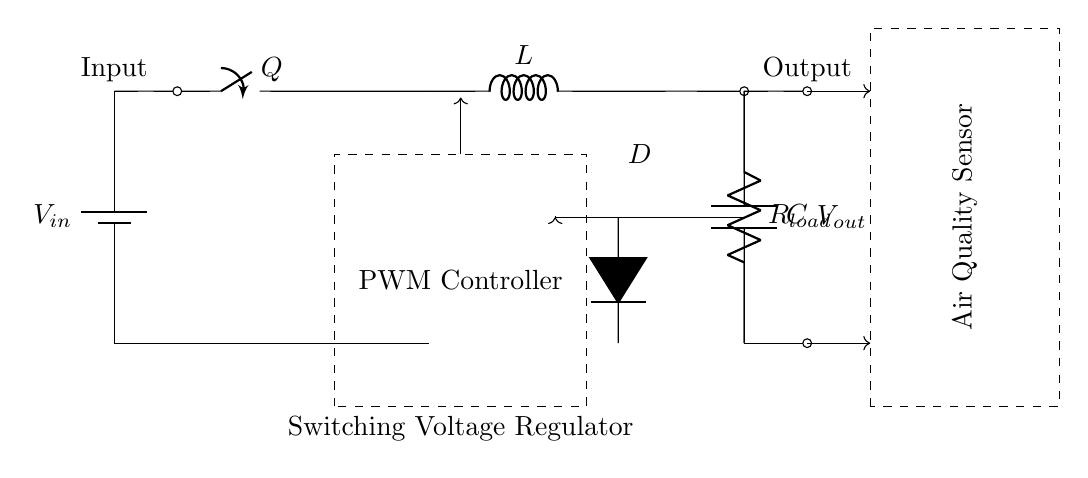What are the components in the circuit? The circuit includes a battery, a switch, an inductor, a diode, a capacitor, a load resistor, and a PWM controller.
Answer: battery, switch, inductor, diode, capacitor, load resistor, PWM controller What does the PWM controller do? The PWM controller regulates the output voltage by controlling the duty cycle of the switch. This results in efficient energy transfer to the load.
Answer: regulate output voltage What is the role of the inductor in this circuit? The inductor stores energy in a magnetic field when current flows through it and releases it when the current stops. This helps in maintaining a steady output voltage.
Answer: store energy What happens to the voltage when the switch is closed? Closing the switch allows current to flow through the inductor, which starts charging the capacitor, resulting in an increase in output voltage.
Answer: output voltage increases Why is the diode included in the circuit? The diode allows current to flow in only one direction, preventing the capacitor from discharging back into the inductor when the switch opens.
Answer: prevent reverse current What type of regulator is this circuit an example of? This circuit is an example of a switching voltage regulator, which effectively converts one voltage level to another with high efficiency.
Answer: switching voltage regulator How does the air quality sensor connect to this circuit? The air quality sensor receives the regulated voltage output from the circuit for its operation, indicated by the arrows showing the flow of electricity from output to the sensor.
Answer: receives regulated voltage 